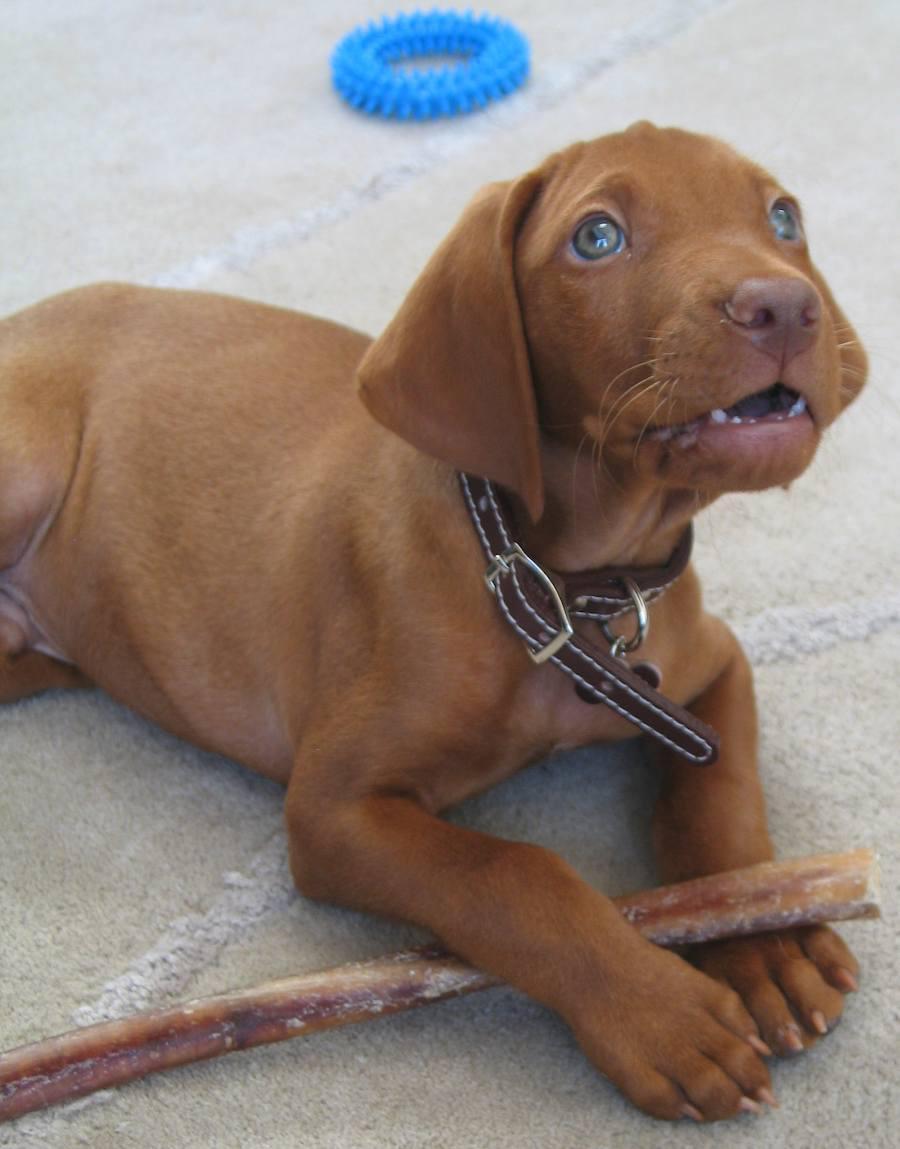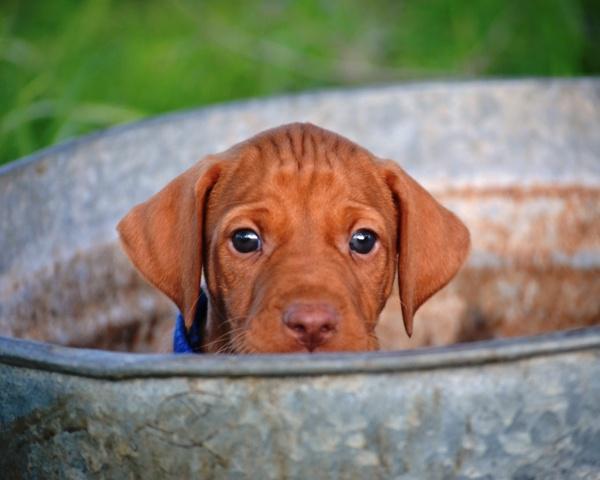The first image is the image on the left, the second image is the image on the right. Analyze the images presented: Is the assertion "The right image features one camera-gazing puppy with fully open eyes, and the left image features one reclining puppy with its front paws forward." valid? Answer yes or no. Yes. The first image is the image on the left, the second image is the image on the right. For the images displayed, is the sentence "A dog is wearing a collar." factually correct? Answer yes or no. Yes. 